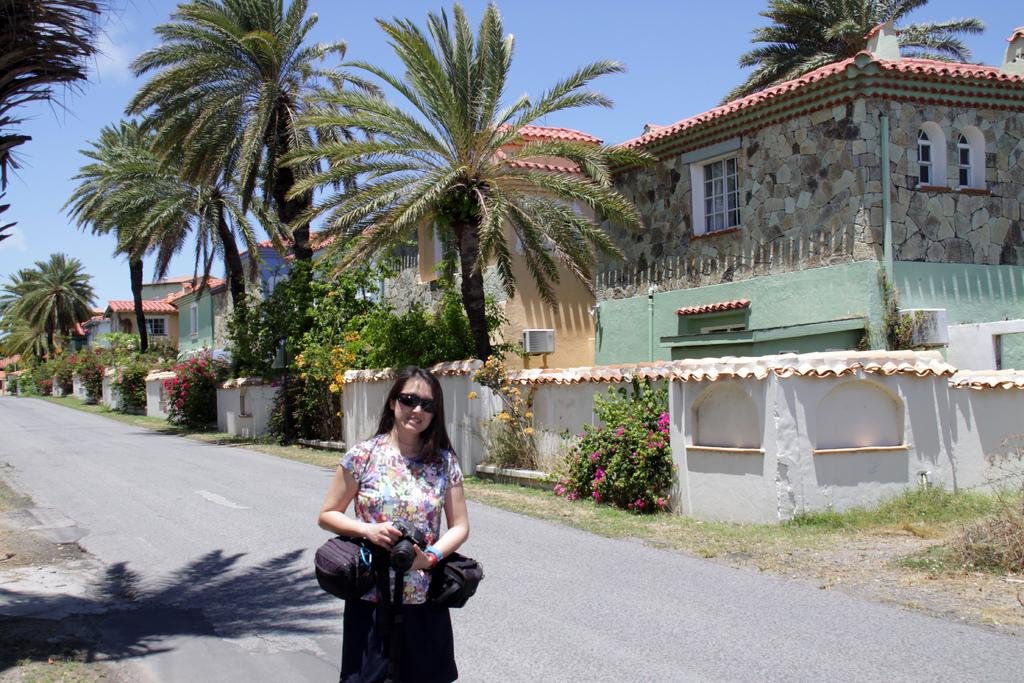Who is present in the image? There is a woman in the image. What is the woman wearing? The woman is wearing spectacles. What is the woman holding in the image? The woman is holding a camera. What can be seen in the background of the image? There are trees, flowers, and buildings in the background of the image. What else is visible in the image? There are bags visible in the image. What book is the woman using as a guide in the image? There is no book or guide present in the image. What type of substance is the woman applying to the camera in the image? There is no substance being applied to the camera in the image. 